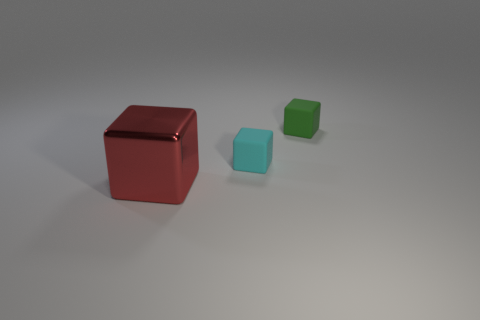There is another object that is the same material as the green thing; what color is it?
Offer a very short reply. Cyan. Is the shape of the green object the same as the big red shiny thing?
Provide a short and direct response. Yes. How many cubes are both to the right of the large red metal thing and in front of the green matte object?
Offer a very short reply. 1. What number of rubber objects are large objects or blue objects?
Your answer should be compact. 0. There is a cube behind the tiny thing that is in front of the green matte block; how big is it?
Make the answer very short. Small. Is there a shiny cube to the right of the small thing that is in front of the small rubber cube to the right of the cyan block?
Your answer should be very brief. No. Is the material of the small cube on the right side of the cyan object the same as the cube in front of the cyan thing?
Provide a short and direct response. No. What number of things are metal things or things that are to the left of the small green rubber cube?
Your response must be concise. 2. How many cyan rubber things have the same shape as the tiny green object?
Keep it short and to the point. 1. There is a green object that is the same size as the cyan block; what is it made of?
Offer a very short reply. Rubber. 